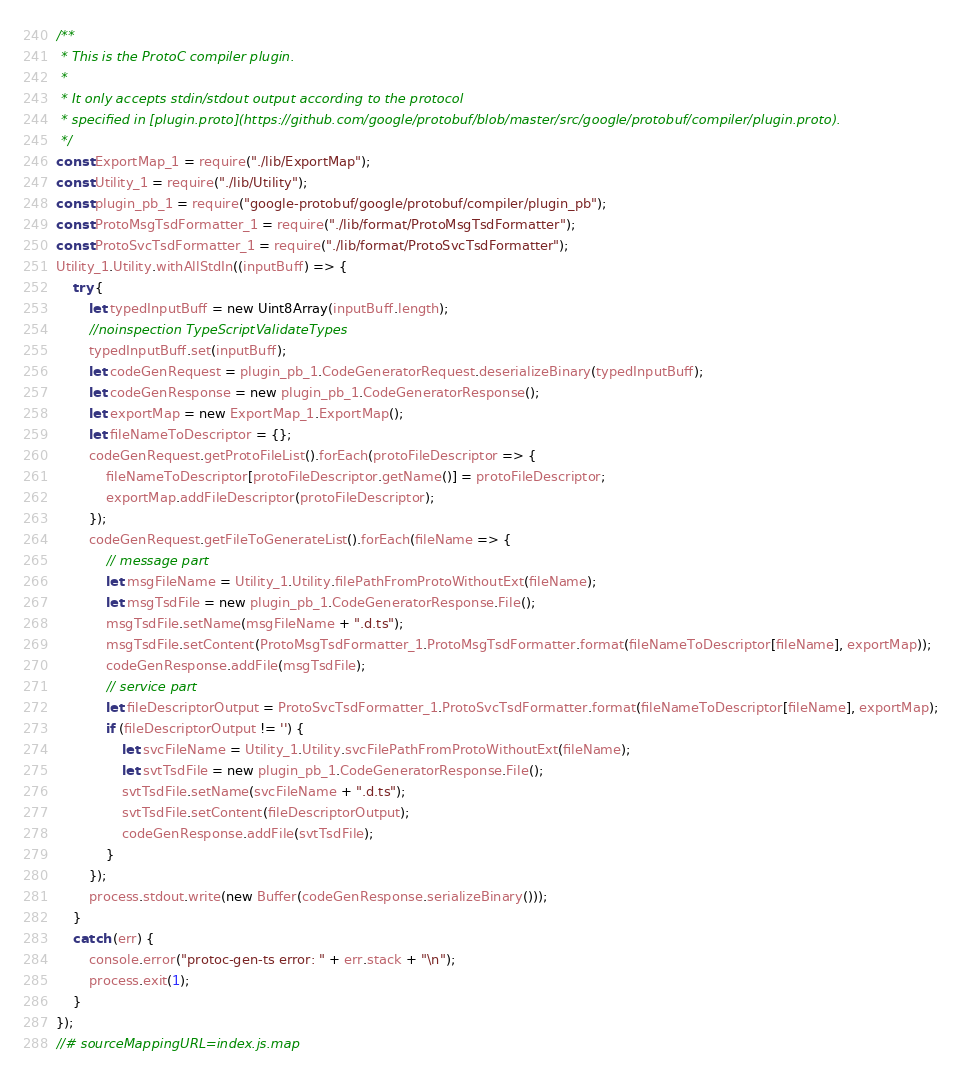Convert code to text. <code><loc_0><loc_0><loc_500><loc_500><_JavaScript_>/**
 * This is the ProtoC compiler plugin.
 *
 * It only accepts stdin/stdout output according to the protocol
 * specified in [plugin.proto](https://github.com/google/protobuf/blob/master/src/google/protobuf/compiler/plugin.proto).
 */
const ExportMap_1 = require("./lib/ExportMap");
const Utility_1 = require("./lib/Utility");
const plugin_pb_1 = require("google-protobuf/google/protobuf/compiler/plugin_pb");
const ProtoMsgTsdFormatter_1 = require("./lib/format/ProtoMsgTsdFormatter");
const ProtoSvcTsdFormatter_1 = require("./lib/format/ProtoSvcTsdFormatter");
Utility_1.Utility.withAllStdIn((inputBuff) => {
    try {
        let typedInputBuff = new Uint8Array(inputBuff.length);
        //noinspection TypeScriptValidateTypes
        typedInputBuff.set(inputBuff);
        let codeGenRequest = plugin_pb_1.CodeGeneratorRequest.deserializeBinary(typedInputBuff);
        let codeGenResponse = new plugin_pb_1.CodeGeneratorResponse();
        let exportMap = new ExportMap_1.ExportMap();
        let fileNameToDescriptor = {};
        codeGenRequest.getProtoFileList().forEach(protoFileDescriptor => {
            fileNameToDescriptor[protoFileDescriptor.getName()] = protoFileDescriptor;
            exportMap.addFileDescriptor(protoFileDescriptor);
        });
        codeGenRequest.getFileToGenerateList().forEach(fileName => {
            // message part
            let msgFileName = Utility_1.Utility.filePathFromProtoWithoutExt(fileName);
            let msgTsdFile = new plugin_pb_1.CodeGeneratorResponse.File();
            msgTsdFile.setName(msgFileName + ".d.ts");
            msgTsdFile.setContent(ProtoMsgTsdFormatter_1.ProtoMsgTsdFormatter.format(fileNameToDescriptor[fileName], exportMap));
            codeGenResponse.addFile(msgTsdFile);
            // service part
            let fileDescriptorOutput = ProtoSvcTsdFormatter_1.ProtoSvcTsdFormatter.format(fileNameToDescriptor[fileName], exportMap);
            if (fileDescriptorOutput != '') {
                let svcFileName = Utility_1.Utility.svcFilePathFromProtoWithoutExt(fileName);
                let svtTsdFile = new plugin_pb_1.CodeGeneratorResponse.File();
                svtTsdFile.setName(svcFileName + ".d.ts");
                svtTsdFile.setContent(fileDescriptorOutput);
                codeGenResponse.addFile(svtTsdFile);
            }
        });
        process.stdout.write(new Buffer(codeGenResponse.serializeBinary()));
    }
    catch (err) {
        console.error("protoc-gen-ts error: " + err.stack + "\n");
        process.exit(1);
    }
});
//# sourceMappingURL=index.js.map</code> 